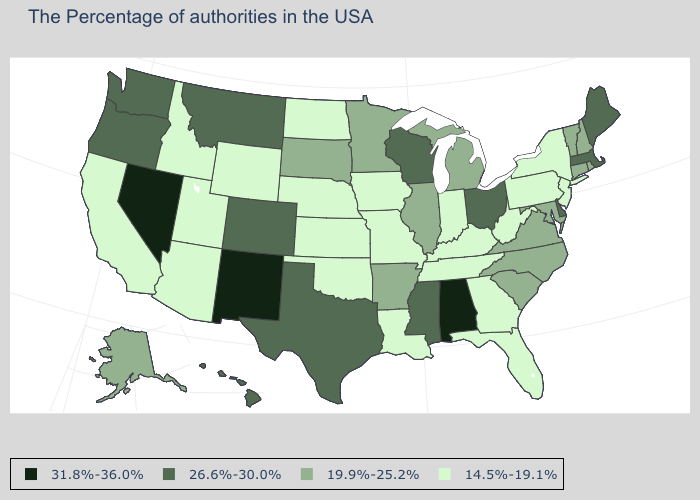What is the value of Kentucky?
Short answer required. 14.5%-19.1%. Name the states that have a value in the range 14.5%-19.1%?
Write a very short answer. New York, New Jersey, Pennsylvania, West Virginia, Florida, Georgia, Kentucky, Indiana, Tennessee, Louisiana, Missouri, Iowa, Kansas, Nebraska, Oklahoma, North Dakota, Wyoming, Utah, Arizona, Idaho, California. Among the states that border Rhode Island , which have the lowest value?
Quick response, please. Connecticut. What is the value of Iowa?
Keep it brief. 14.5%-19.1%. Which states have the lowest value in the USA?
Be succinct. New York, New Jersey, Pennsylvania, West Virginia, Florida, Georgia, Kentucky, Indiana, Tennessee, Louisiana, Missouri, Iowa, Kansas, Nebraska, Oklahoma, North Dakota, Wyoming, Utah, Arizona, Idaho, California. Does the map have missing data?
Be succinct. No. What is the value of Montana?
Give a very brief answer. 26.6%-30.0%. Is the legend a continuous bar?
Concise answer only. No. Name the states that have a value in the range 31.8%-36.0%?
Be succinct. Alabama, New Mexico, Nevada. Does North Carolina have the highest value in the USA?
Keep it brief. No. Among the states that border Wisconsin , does Michigan have the highest value?
Short answer required. Yes. Name the states that have a value in the range 26.6%-30.0%?
Quick response, please. Maine, Massachusetts, Delaware, Ohio, Wisconsin, Mississippi, Texas, Colorado, Montana, Washington, Oregon, Hawaii. What is the highest value in the South ?
Write a very short answer. 31.8%-36.0%. Name the states that have a value in the range 31.8%-36.0%?
Short answer required. Alabama, New Mexico, Nevada. 